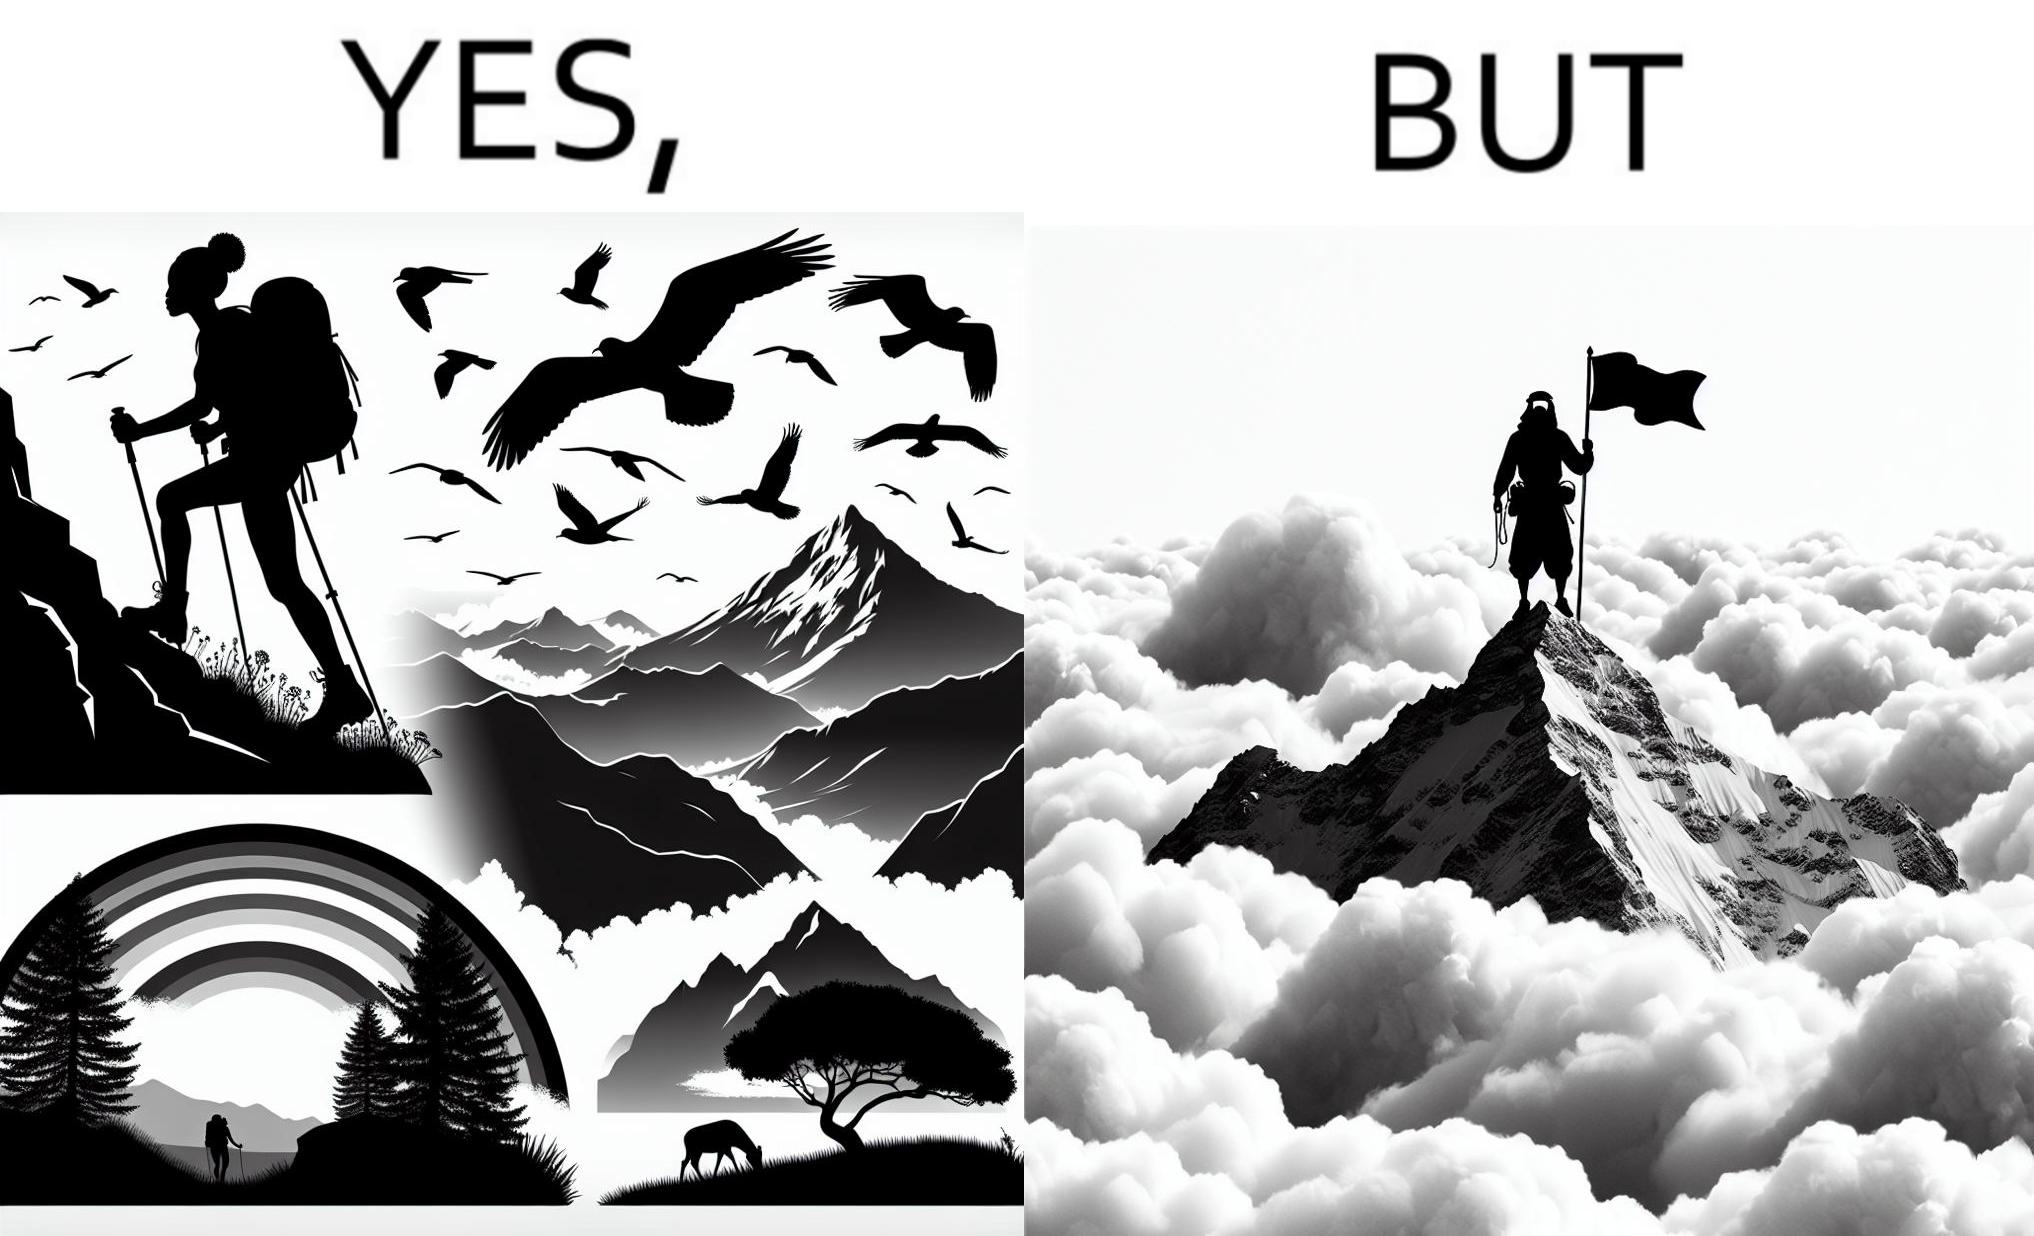What does this image depict? The image is ironic, because the mountaineer climbs up the mountain to view the world from the peak but due to so much cloud, at the top, nothing is visible whereas he was able to witness some awesome views while climbing up the mountain 